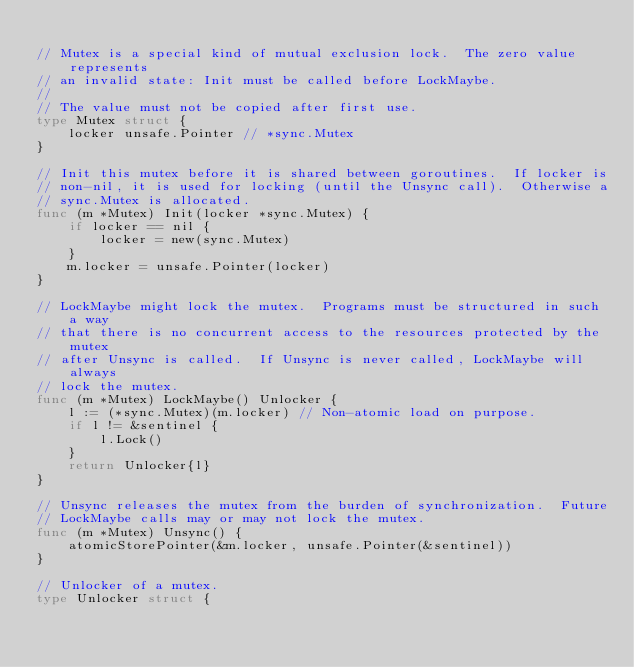Convert code to text. <code><loc_0><loc_0><loc_500><loc_500><_Go_>
// Mutex is a special kind of mutual exclusion lock.  The zero value represents
// an invalid state: Init must be called before LockMaybe.
//
// The value must not be copied after first use.
type Mutex struct {
	locker unsafe.Pointer // *sync.Mutex
}

// Init this mutex before it is shared between goroutines.  If locker is
// non-nil, it is used for locking (until the Unsync call).  Otherwise a
// sync.Mutex is allocated.
func (m *Mutex) Init(locker *sync.Mutex) {
	if locker == nil {
		locker = new(sync.Mutex)
	}
	m.locker = unsafe.Pointer(locker)
}

// LockMaybe might lock the mutex.  Programs must be structured in such a way
// that there is no concurrent access to the resources protected by the mutex
// after Unsync is called.  If Unsync is never called, LockMaybe will always
// lock the mutex.
func (m *Mutex) LockMaybe() Unlocker {
	l := (*sync.Mutex)(m.locker) // Non-atomic load on purpose.
	if l != &sentinel {
		l.Lock()
	}
	return Unlocker{l}
}

// Unsync releases the mutex from the burden of synchronization.  Future
// LockMaybe calls may or may not lock the mutex.
func (m *Mutex) Unsync() {
	atomicStorePointer(&m.locker, unsafe.Pointer(&sentinel))
}

// Unlocker of a mutex.
type Unlocker struct {</code> 